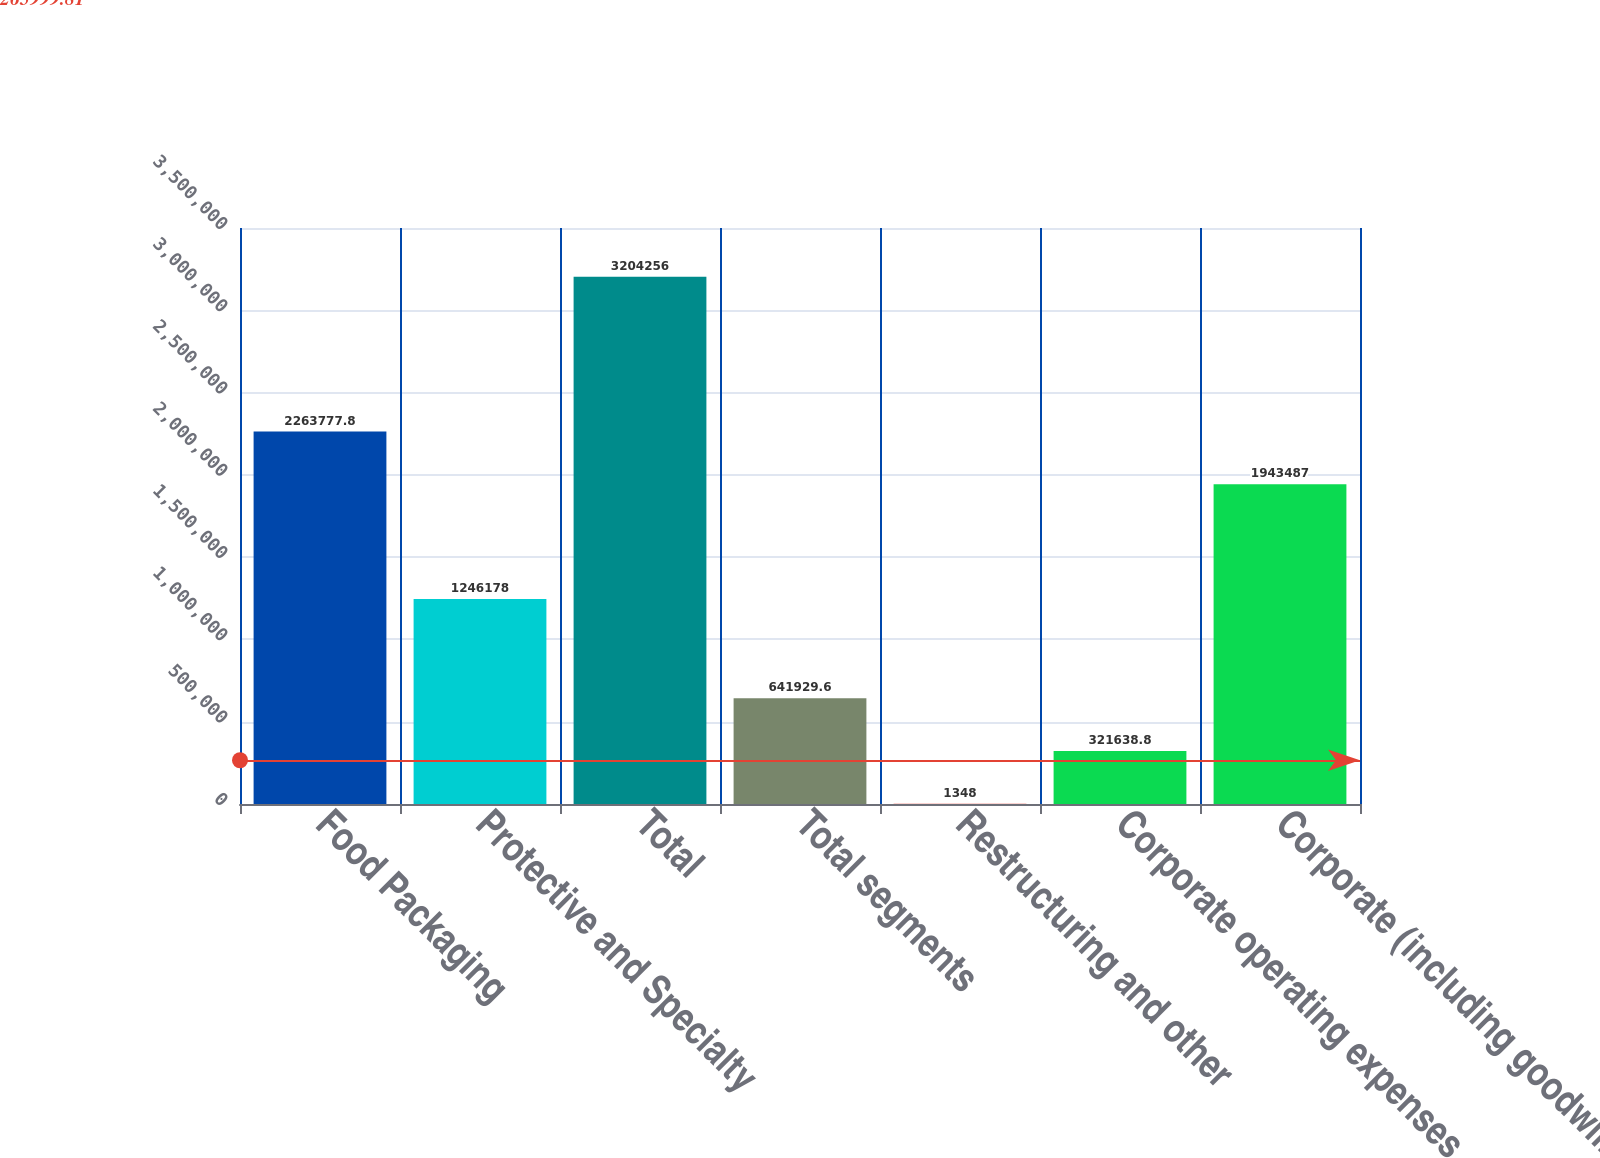Convert chart to OTSL. <chart><loc_0><loc_0><loc_500><loc_500><bar_chart><fcel>Food Packaging<fcel>Protective and Specialty<fcel>Total<fcel>Total segments<fcel>Restructuring and other<fcel>Corporate operating expenses<fcel>Corporate (including goodwill<nl><fcel>2.26378e+06<fcel>1.24618e+06<fcel>3.20426e+06<fcel>641930<fcel>1348<fcel>321639<fcel>1.94349e+06<nl></chart> 